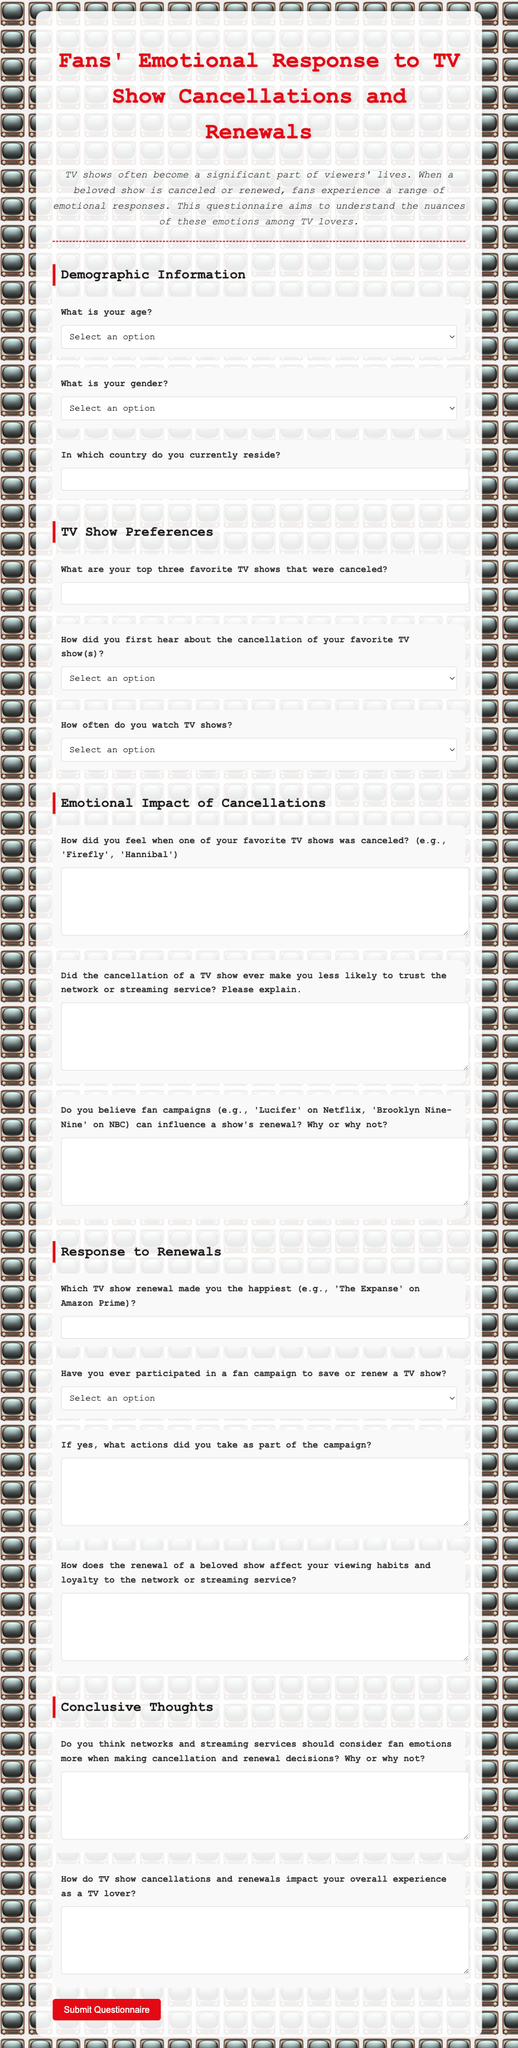What is the title of the questionnaire? The title is prominently displayed at the top of the document, which is "Fans' Emotional Response to TV Show Cancellations and Renewals."
Answer: Fans' Emotional Response to TV Show Cancellations and Renewals What age group is included in the options? The options for age groups are listed in a select menu, including "Under 18," "18-24," "25-34," "35-44," "45-54," "55-64," and "65 and above."
Answer: Under 18, 18-24, 25-34, 35-44, 45-54, 55-64, 65 and above Which question asks about the impact of cancellations on trust? The specific question inquiring about trust relates directly to the impact of cancellations and is phrased as "Did the cancellation of a TV show ever make you less likely to trust the network or streaming service? Please explain."
Answer: Did the cancellation of a TV show ever make you less likely to trust the network or streaming service? Please explain Which section addresses the emotional impact of cancellations? This specific area of the questionnaire is titled "Emotional Impact of Cancellations," which includes several related questions.
Answer: Emotional Impact of Cancellations What is the label for the question regarding fan campaigns? The label for this question is "Do you believe fan campaigns (e.g., 'Lucifer' on Netflix, 'Brooklyn Nine-Nine' on NBC) can influence a show's renewal? Why or why not?"
Answer: Do you believe fan campaigns (e.g., 'Lucifer' on Netflix, 'Brooklyn Nine-Nine' on NBC) can influence a show's renewal? Why or why not? What is the prompt for the section on renewal effects? The section exploring the effects of renewals is introduced with the heading "Response to Renewals."
Answer: Response to Renewals How does the questionnaire request feedback on overall impact? It requests feedback through the question "How do TV show cancellations and renewals impact your overall experience as a TV lover?"
Answer: How do TV show cancellations and renewals impact your overall experience as a TV lover? 